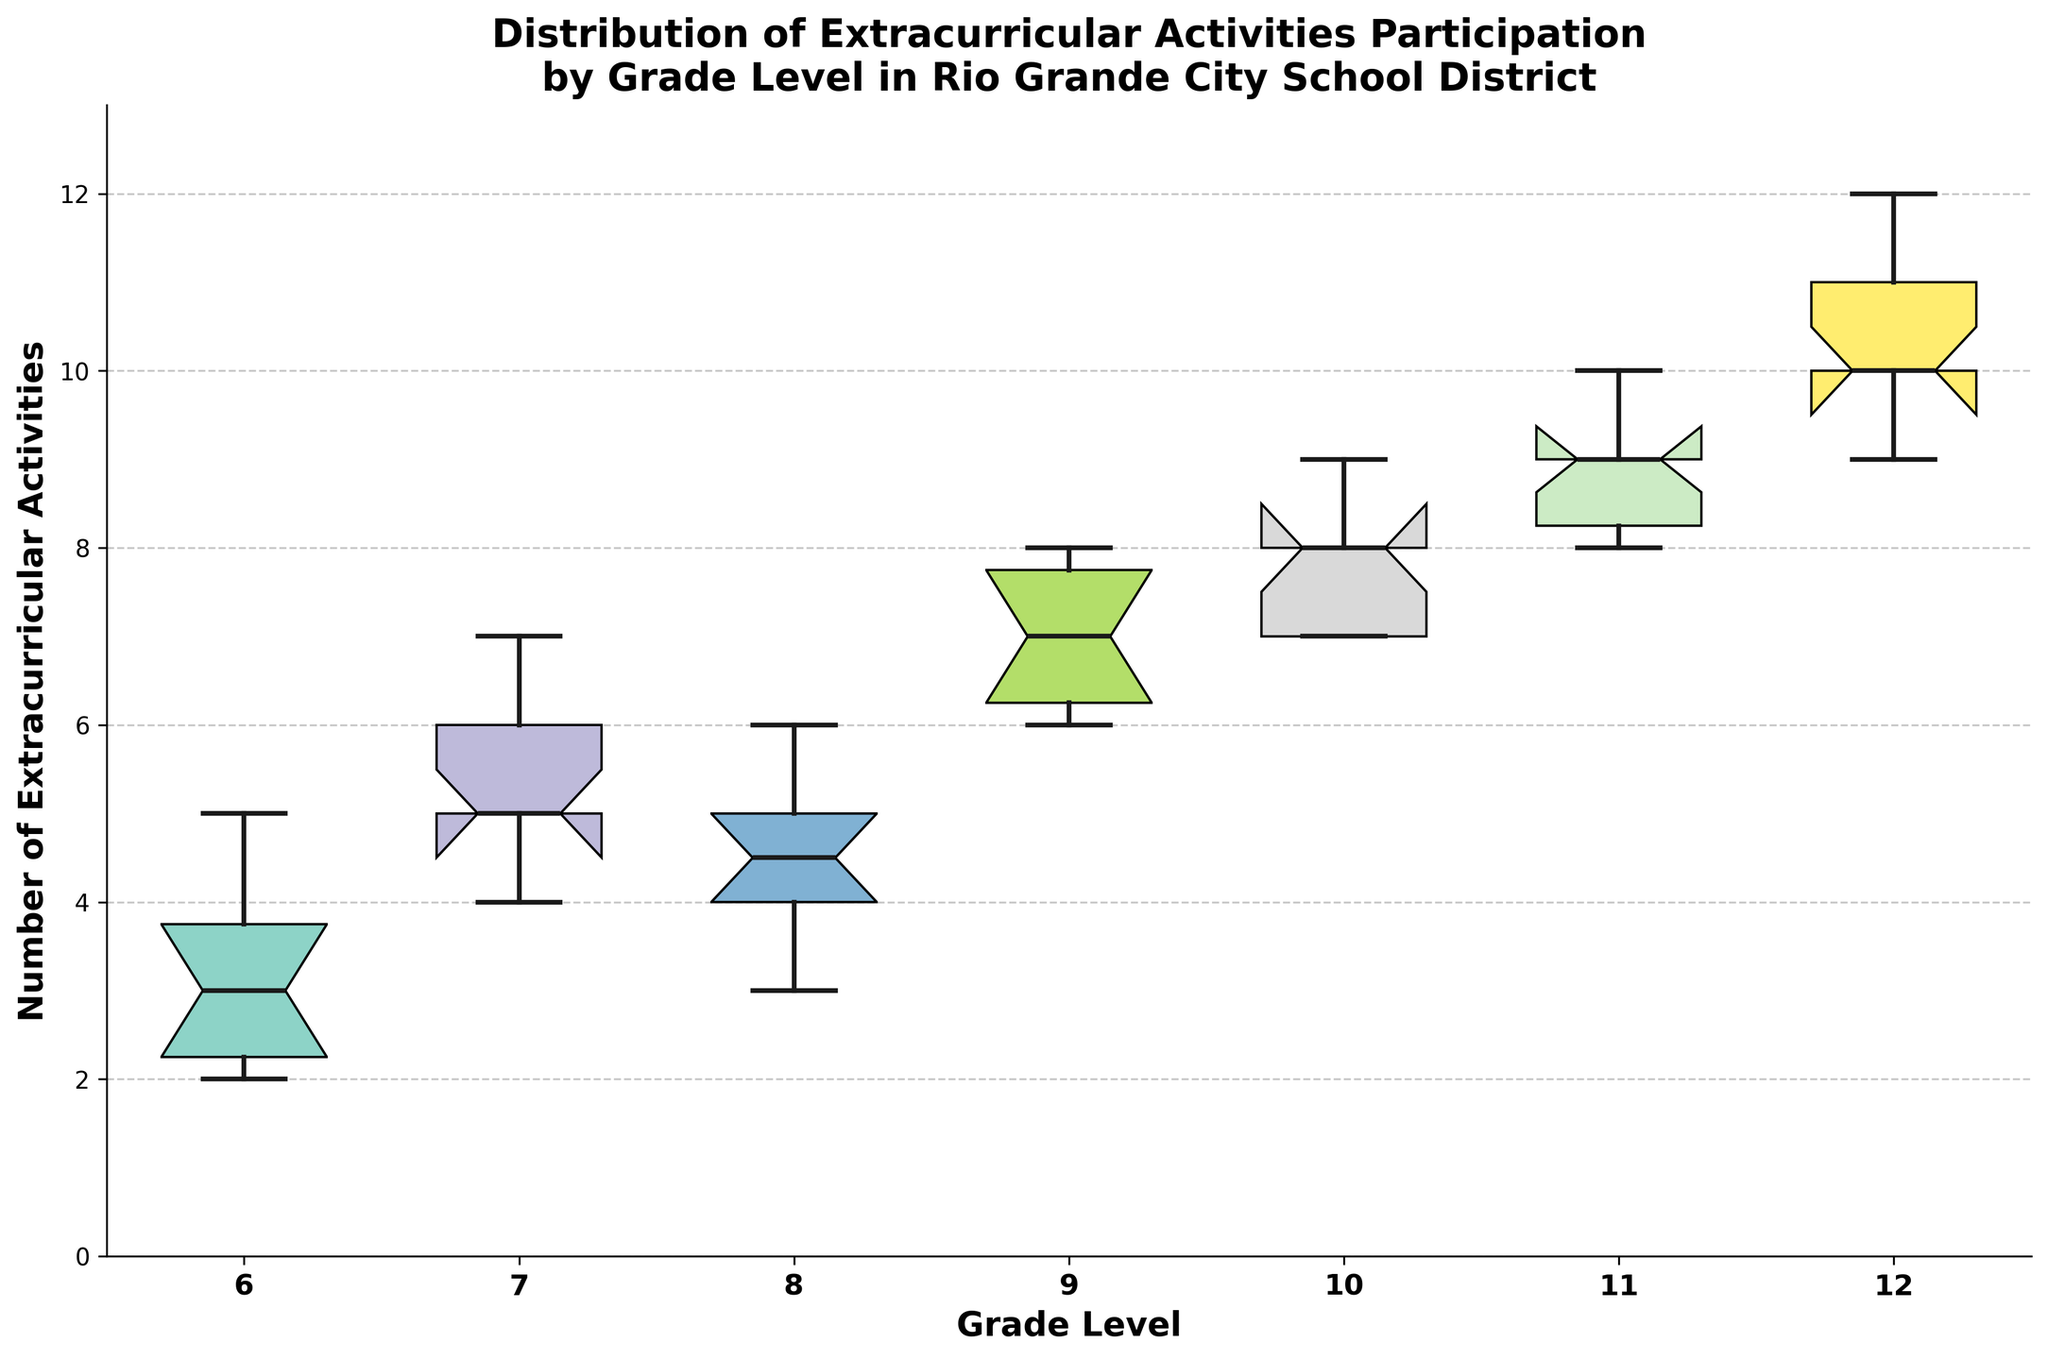What's the title of the plot? The title is usually displayed at the top of the plot and provides an overview of what the plot is about.
Answer: Distribution of Extracurricular Activities Participation by Grade Level in Rio Grande City School District What's the median number of extracurricular activities for 9th grade? The median is represented by the line inside the box for each grade level. For 9th grade, this line is at 7.
Answer: 7 Which grade level has the highest median number of extracurricular activities? Compare the lines inside the boxes which represent the medians for each grade. The 12th-grade box has the highest median line.
Answer: 12th grade What is the range of extracurricular activities for 6th grade? The range is determined by the bottom and top of the whiskers for 6th grade. The lowest point is 2; the highest point is 5.
Answer: 2 to 5 How does the activity participation of 7th grade compare to 11th grade in terms of median? The median is the line inside the box. The median for 7th grade is 5, whereas the median for 11th grade is 9.
Answer: The median for 7th grade is lower than that for 11th grade Which grade level has the widest interquartile range (IQR) of participation in extracurricular activities? The IQR is the distance between the bottom and top of the box. For 12th grade, this box spans from 10 to 11.
Answer: 12th grade How many unique grade levels are represented in the plot? Count the number of distinct boxes on the x-axis, each representing a grade level.
Answer: 7 Which grade level shows the least variability in extracurricular activities participation? The variability is represented by the length of the box and whiskers. The 6th-grade box and whiskers span the shortest range.
Answer: 6th grade What is the upper whisker value for 10th grade? The upper whisker is the top end of the line extending from the box. For 10th grade, this value is 9.
Answer: 9 Are there any outliers in the extracurricular activities participation for any grade level? Outliers would be marked as individual points outside the whiskers. No grade level has such outliers in this plot.
Answer: No 